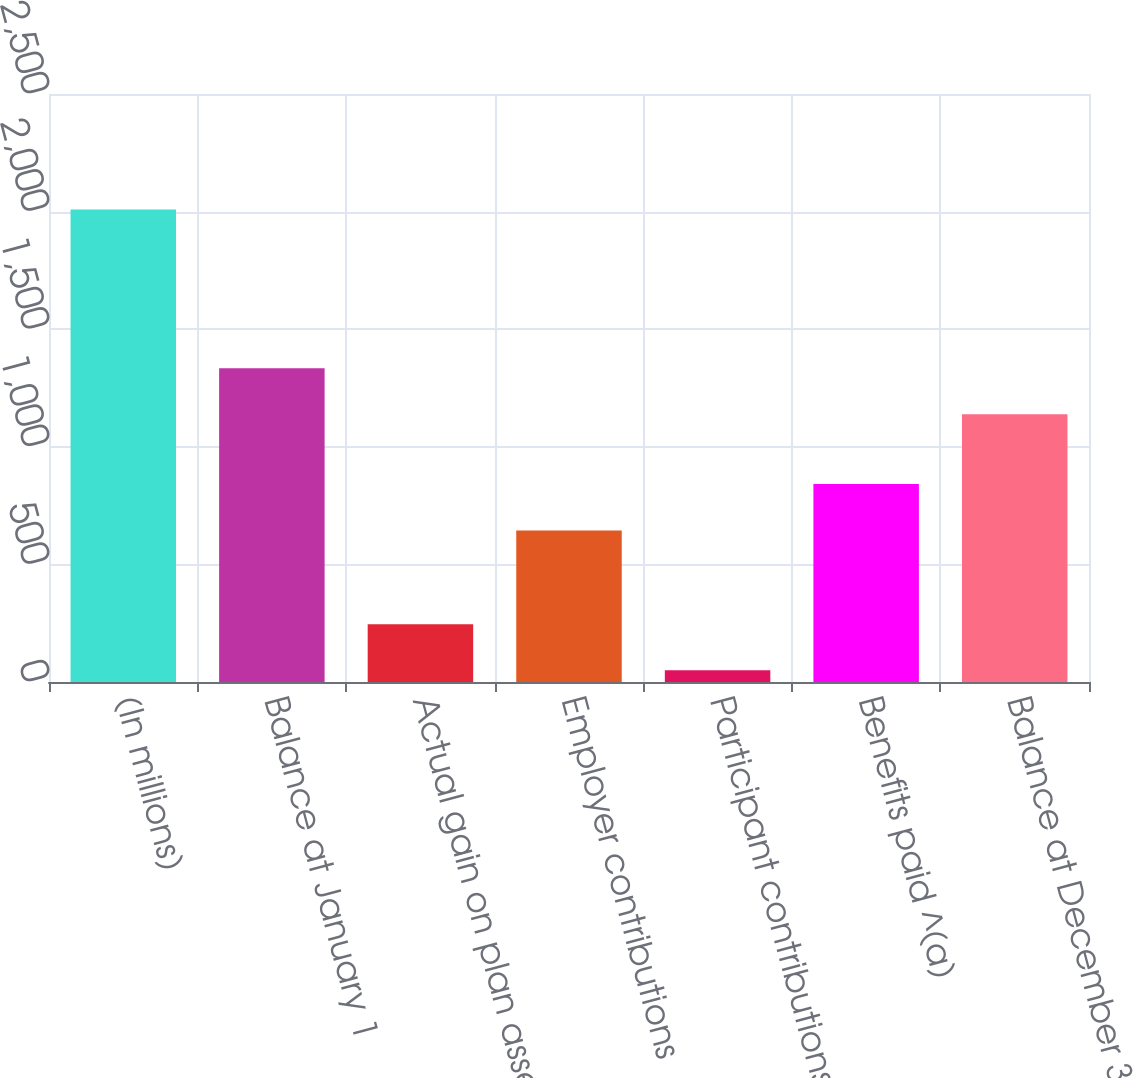<chart> <loc_0><loc_0><loc_500><loc_500><bar_chart><fcel>(In millions)<fcel>Balance at January 1<fcel>Actual gain on plan assets<fcel>Employer contributions<fcel>Participant contributions<fcel>Benefits paid ^(a)<fcel>Balance at December 31<nl><fcel>2009<fcel>1333.9<fcel>245.9<fcel>644<fcel>50<fcel>842<fcel>1138<nl></chart> 